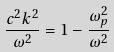<formula> <loc_0><loc_0><loc_500><loc_500>\frac { c ^ { 2 } k ^ { 2 } } { \omega ^ { 2 } } = 1 - \frac { \omega _ { p } ^ { 2 } } { \omega ^ { 2 } }</formula> 